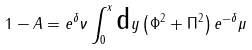<formula> <loc_0><loc_0><loc_500><loc_500>1 - A = e ^ { \delta } \nu \int _ { 0 } ^ { x } \text {d} y \left ( \Phi ^ { 2 } + \Pi ^ { 2 } \right ) e ^ { - \delta } \mu</formula> 